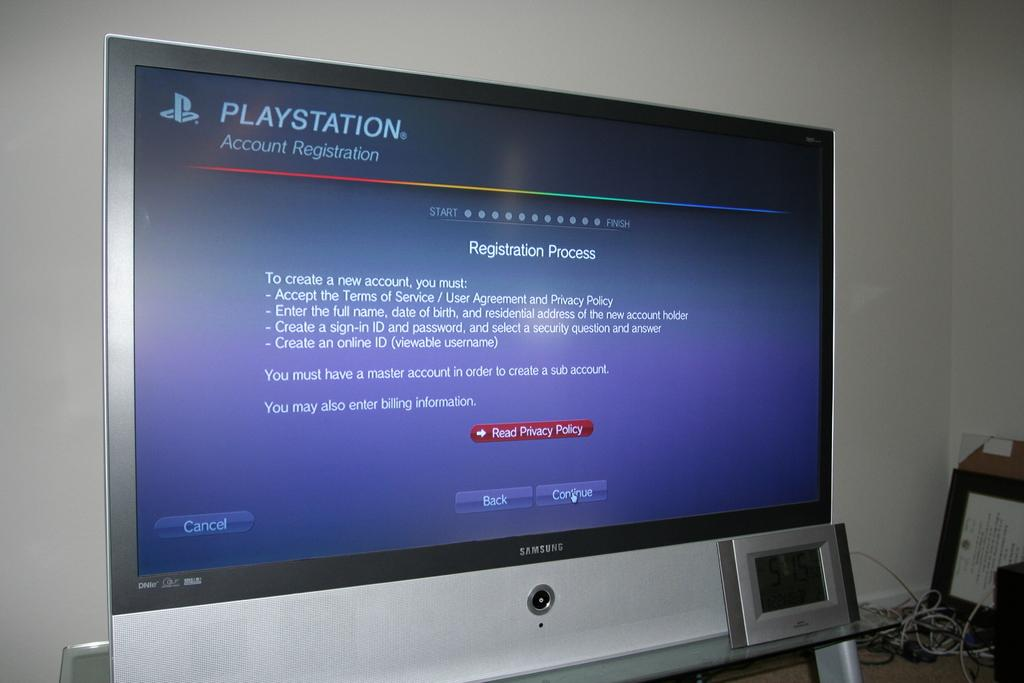<image>
Present a compact description of the photo's key features. A large TV is showing the Playstation Account Registration page, and you can click the red button to Read Privacy Policy. 